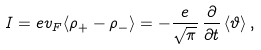<formula> <loc_0><loc_0><loc_500><loc_500>I = e v _ { F } \langle \rho _ { + } - \rho _ { - } \rangle = - \frac { e } { \sqrt { \pi } } \, \frac { \partial } { \partial t } \, \langle \vartheta \rangle \, ,</formula> 